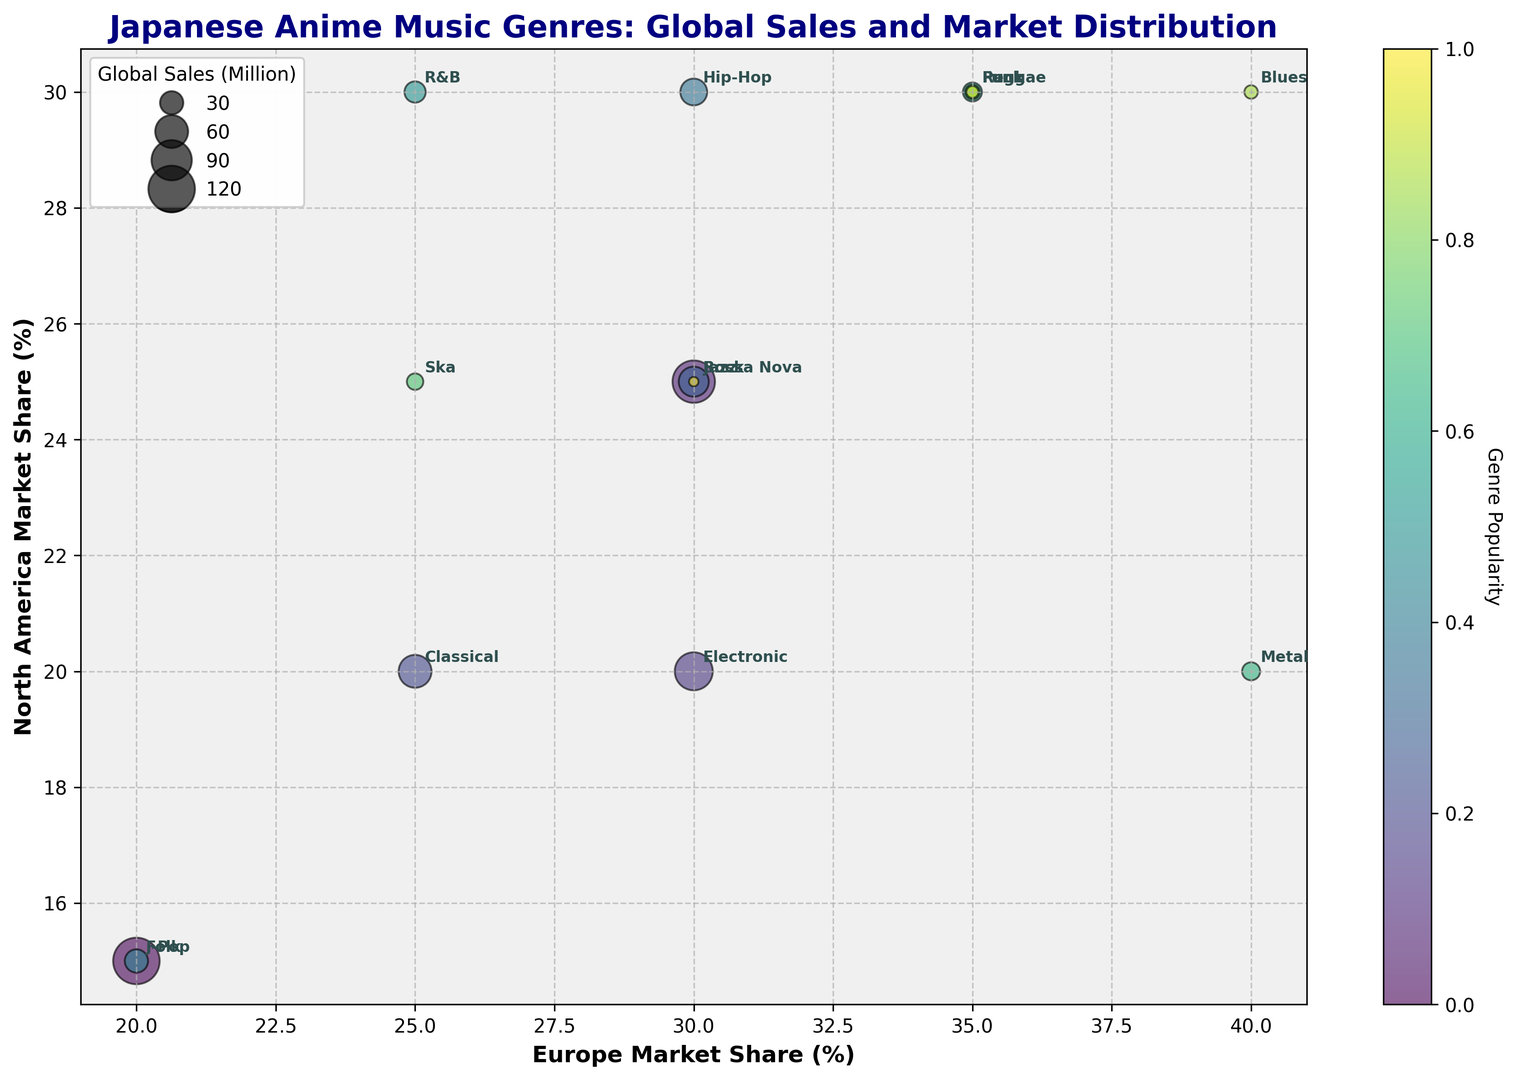Which genre has the highest global sales? By looking at the size of the bubbles, the largest bubble represents the highest global sales. The "J-Pop" genre has the largest bubble.
Answer: J-Pop Which genre has the highest market share in Europe? By looking along the x-axis for the highest value, we see that "Blues" hits 40%, which is the highest among all genres.
Answer: Blues Which genre has the highest market share in North America? By observing the y-axis for the highest value, "Blues" again reaches the highest market share at 30%.
Answer: Blues Which genre has a larger global sales, Rock or Hip-Hop? By comparing the size of the bubbles, Rock has a larger bubble than Hip-Hop, indicating higher global sales.
Answer: Rock Which genres have a higher market share in Asia compared to Europe? Look for the genres where the Asia percentage is greater than the Europe percentage. J-Pop, Folk, and Classical fall into this category.
Answer: J-Pop, Folk, Classical Which genre has the lowest global sales? The smallest bubble represents the lowest global sales. The "Bossa Nova" genre has the smallest bubble.
Answer: Bossa Nova How does the market share distribution of Electronic compare to Jazz between Europe and North America? Comparing the position of both genres on the x and y axes, Electronic has 30% in Europe and 20% in North America, whereas Jazz has 35% in Europe and 25% in North America.
Answer: Jazz has a higher market share in both Europe and North America Which genre has the highest disparity between the market share in Europe and North America? By calculating the absolute difference between the x and y values, Metal has the highest disparity with 40% in Europe and 20% in North America (40% - 20% = 20%).
Answer: Metal What is the combined market share of R&B in Europe and North America? Sum the percentages: 25% (Europe) + 30% (North America) = 55%.
Answer: 55% Which genres' market shares in Europe and North America are near equal? Look for genres plotted along the line y=x. Both Punk and Reggae have similar market shares in Europe and North America with Punk having 35% in Europe and 30% in North America, and Reggae having 35% in Europe and 30% in North America.
Answer: Punk, Reggae 